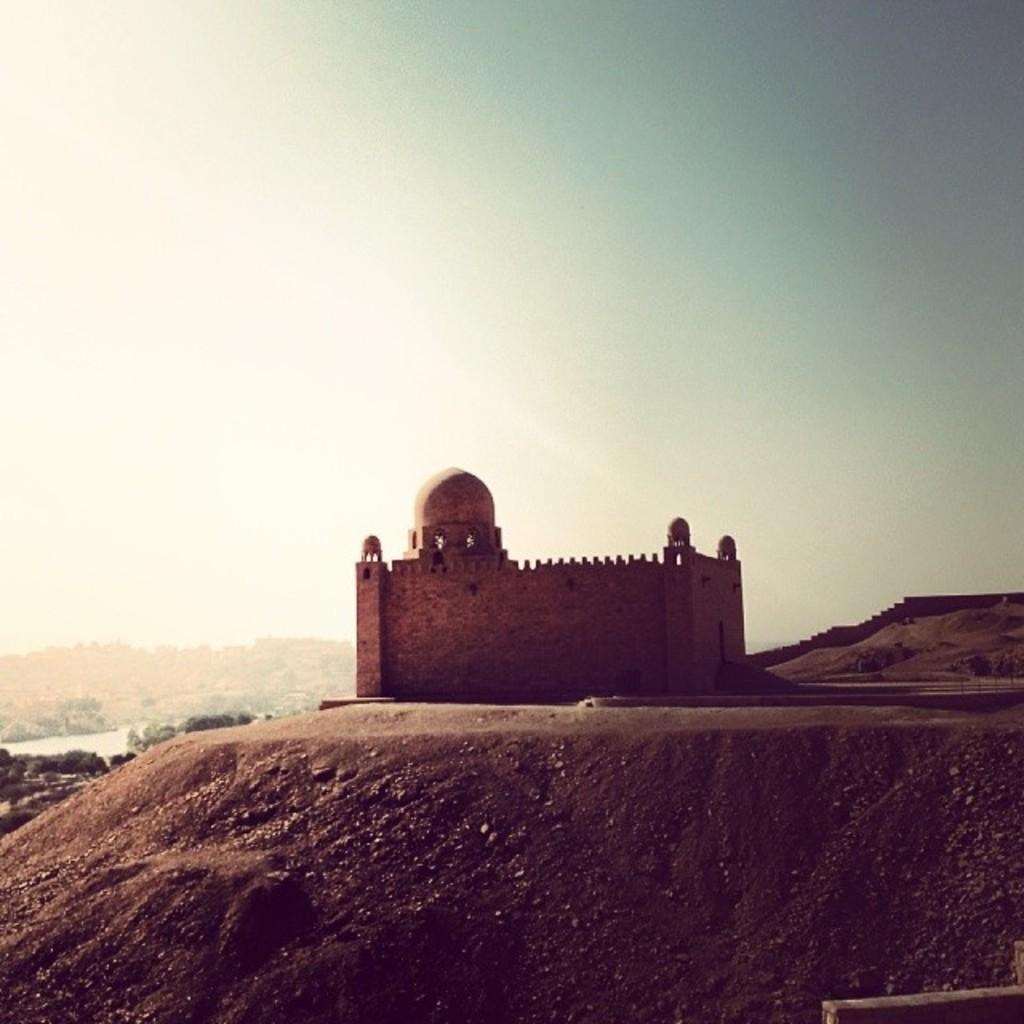How would you summarize this image in a sentence or two? In this picture there is a monument on the mountain. In the background I can see other mountains, wall and trees. On the left I can see the water. At the top I can see the sky. 